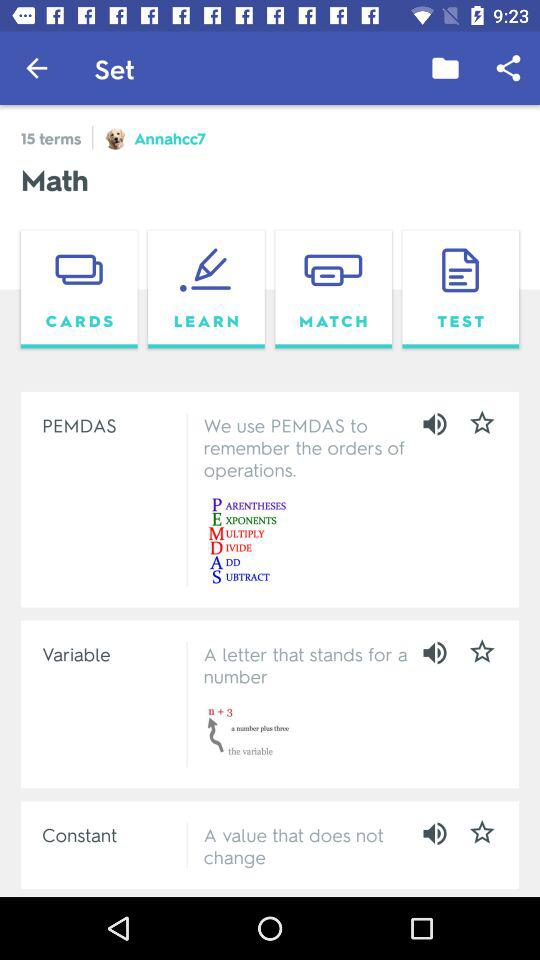How many terms are there? There are 15 terms. 